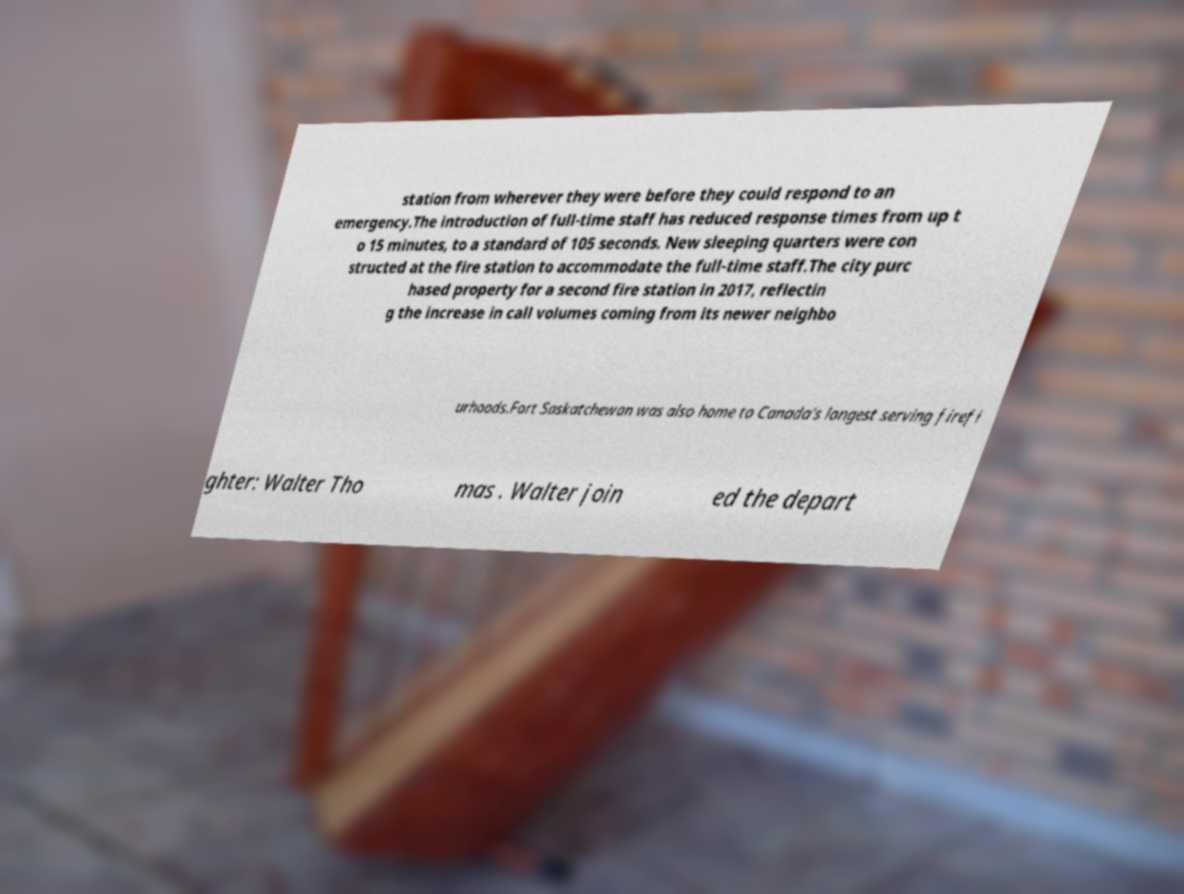I need the written content from this picture converted into text. Can you do that? station from wherever they were before they could respond to an emergency.The introduction of full-time staff has reduced response times from up t o 15 minutes, to a standard of 105 seconds. New sleeping quarters were con structed at the fire station to accommodate the full-time staff.The city purc hased property for a second fire station in 2017, reflectin g the increase in call volumes coming from its newer neighbo urhoods.Fort Saskatchewan was also home to Canada's longest serving firefi ghter: Walter Tho mas . Walter join ed the depart 